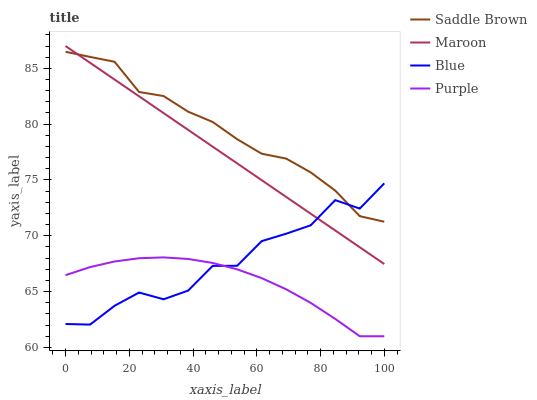Does Purple have the minimum area under the curve?
Answer yes or no. Yes. Does Saddle Brown have the maximum area under the curve?
Answer yes or no. Yes. Does Saddle Brown have the minimum area under the curve?
Answer yes or no. No. Does Purple have the maximum area under the curve?
Answer yes or no. No. Is Maroon the smoothest?
Answer yes or no. Yes. Is Blue the roughest?
Answer yes or no. Yes. Is Purple the smoothest?
Answer yes or no. No. Is Purple the roughest?
Answer yes or no. No. Does Purple have the lowest value?
Answer yes or no. Yes. Does Saddle Brown have the lowest value?
Answer yes or no. No. Does Maroon have the highest value?
Answer yes or no. Yes. Does Saddle Brown have the highest value?
Answer yes or no. No. Is Purple less than Maroon?
Answer yes or no. Yes. Is Saddle Brown greater than Purple?
Answer yes or no. Yes. Does Blue intersect Saddle Brown?
Answer yes or no. Yes. Is Blue less than Saddle Brown?
Answer yes or no. No. Is Blue greater than Saddle Brown?
Answer yes or no. No. Does Purple intersect Maroon?
Answer yes or no. No. 